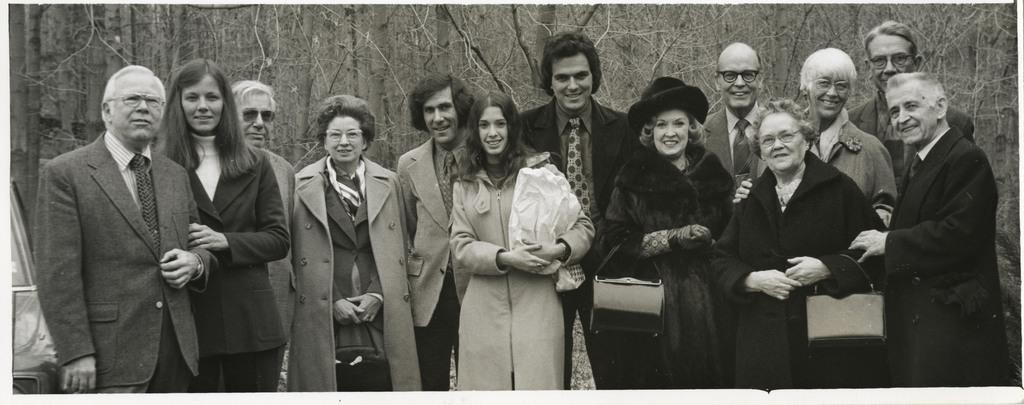What is the color scheme of the image? The image is in black and white. Who can be seen in the image? There are men and women standing in the image. What is the facial expression of the people in the image? The people are smiling. What can be seen in the background of the image? There are trees visible in the background of the image. Can you tell me how many cattle are present in the image? There are no cattle present in the image; it features men and women standing in front of trees. Is there a baseball game happening in the image? There is no baseball game present in the image; it shows people standing and smiling. 